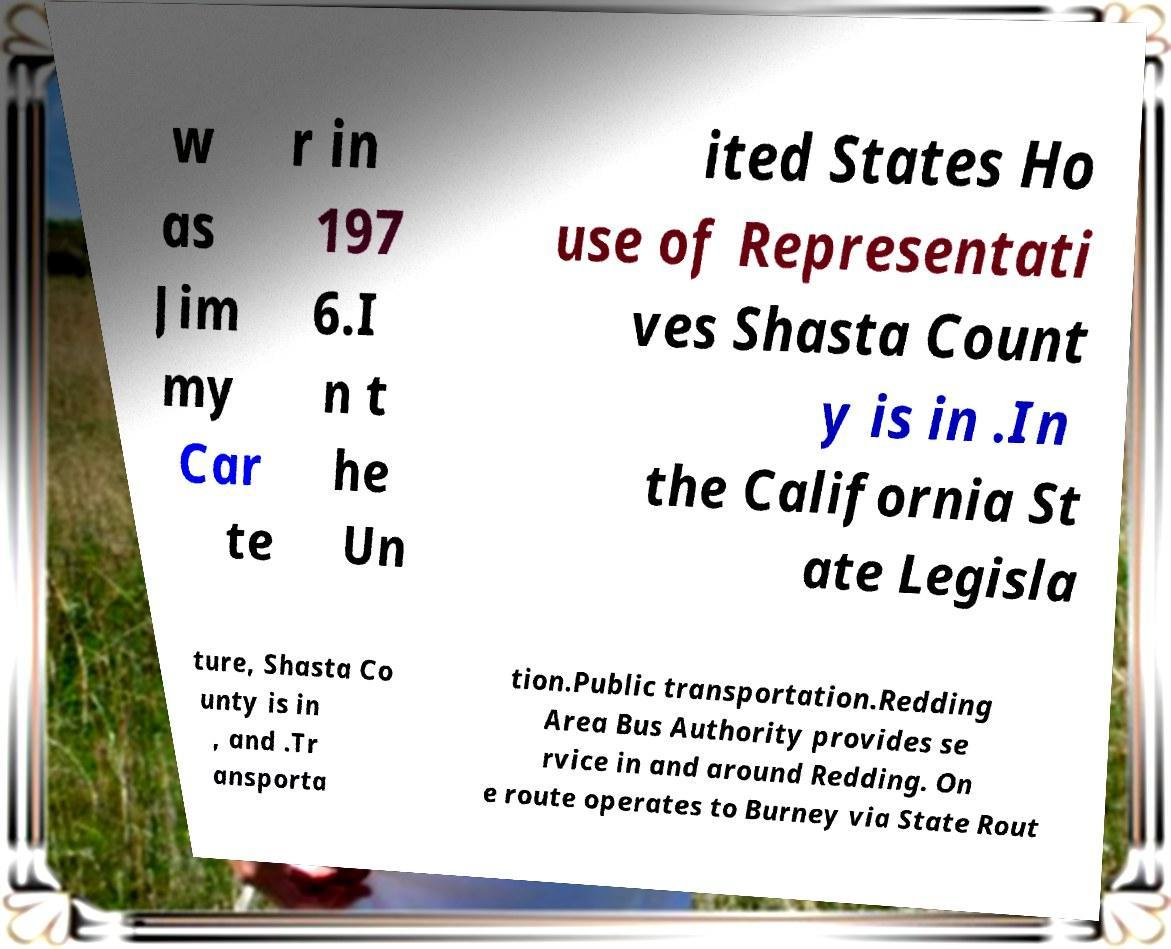Could you extract and type out the text from this image? w as Jim my Car te r in 197 6.I n t he Un ited States Ho use of Representati ves Shasta Count y is in .In the California St ate Legisla ture, Shasta Co unty is in , and .Tr ansporta tion.Public transportation.Redding Area Bus Authority provides se rvice in and around Redding. On e route operates to Burney via State Rout 